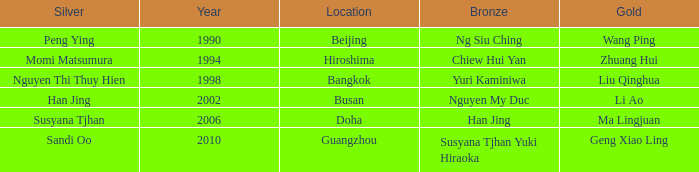What Silver has a Golf of Li AO? Han Jing. 